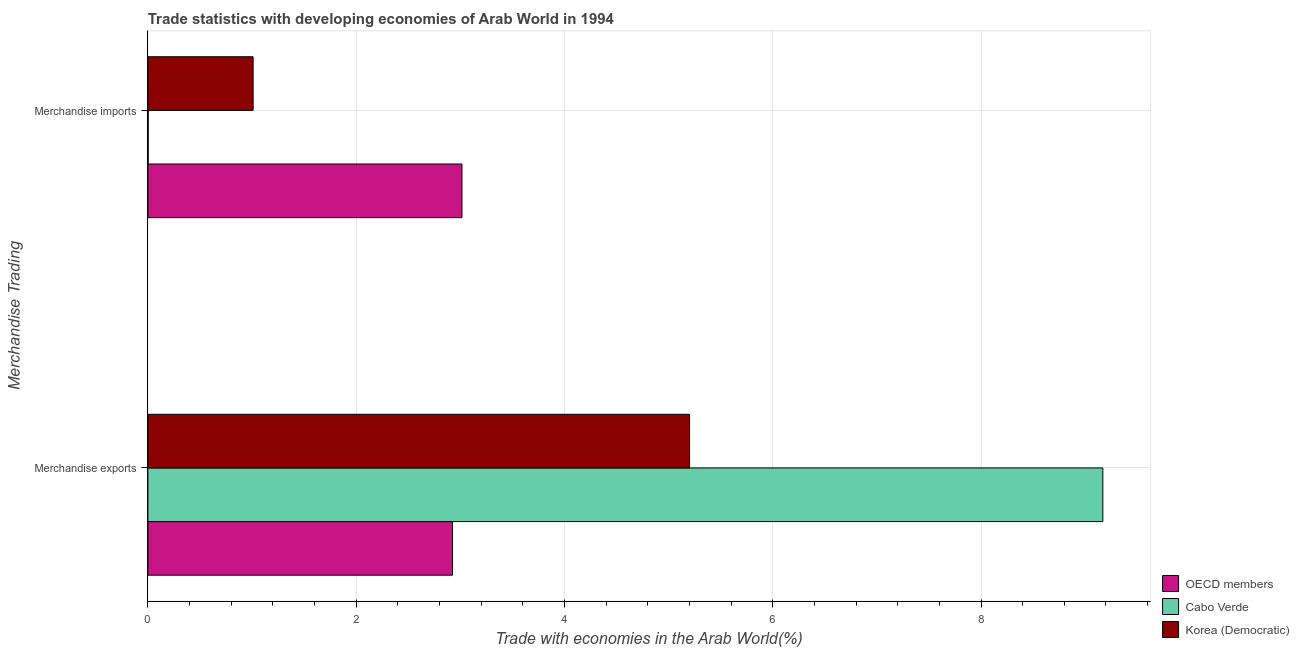Are the number of bars per tick equal to the number of legend labels?
Give a very brief answer. Yes. How many bars are there on the 2nd tick from the top?
Make the answer very short. 3. How many bars are there on the 2nd tick from the bottom?
Your response must be concise. 3. What is the label of the 1st group of bars from the top?
Your answer should be compact. Merchandise imports. What is the merchandise exports in Korea (Democratic)?
Give a very brief answer. 5.2. Across all countries, what is the maximum merchandise imports?
Offer a terse response. 3.02. Across all countries, what is the minimum merchandise exports?
Offer a very short reply. 2.93. In which country was the merchandise exports maximum?
Your response must be concise. Cabo Verde. What is the total merchandise imports in the graph?
Your answer should be compact. 4.03. What is the difference between the merchandise exports in Cabo Verde and that in OECD members?
Offer a terse response. 6.24. What is the difference between the merchandise imports in Korea (Democratic) and the merchandise exports in Cabo Verde?
Give a very brief answer. -8.16. What is the average merchandise exports per country?
Give a very brief answer. 5.77. What is the difference between the merchandise imports and merchandise exports in OECD members?
Offer a terse response. 0.09. In how many countries, is the merchandise exports greater than 0.4 %?
Your response must be concise. 3. What is the ratio of the merchandise exports in Korea (Democratic) to that in Cabo Verde?
Your answer should be compact. 0.57. What does the 3rd bar from the bottom in Merchandise exports represents?
Offer a terse response. Korea (Democratic). Are all the bars in the graph horizontal?
Make the answer very short. Yes. Does the graph contain any zero values?
Offer a very short reply. No. Does the graph contain grids?
Offer a terse response. Yes. What is the title of the graph?
Your answer should be compact. Trade statistics with developing economies of Arab World in 1994. What is the label or title of the X-axis?
Your answer should be compact. Trade with economies in the Arab World(%). What is the label or title of the Y-axis?
Keep it short and to the point. Merchandise Trading. What is the Trade with economies in the Arab World(%) in OECD members in Merchandise exports?
Your response must be concise. 2.93. What is the Trade with economies in the Arab World(%) of Cabo Verde in Merchandise exports?
Give a very brief answer. 9.17. What is the Trade with economies in the Arab World(%) in Korea (Democratic) in Merchandise exports?
Your answer should be very brief. 5.2. What is the Trade with economies in the Arab World(%) in OECD members in Merchandise imports?
Your response must be concise. 3.02. What is the Trade with economies in the Arab World(%) of Cabo Verde in Merchandise imports?
Ensure brevity in your answer.  0. What is the Trade with economies in the Arab World(%) of Korea (Democratic) in Merchandise imports?
Your answer should be very brief. 1.01. Across all Merchandise Trading, what is the maximum Trade with economies in the Arab World(%) in OECD members?
Offer a terse response. 3.02. Across all Merchandise Trading, what is the maximum Trade with economies in the Arab World(%) in Cabo Verde?
Offer a very short reply. 9.17. Across all Merchandise Trading, what is the maximum Trade with economies in the Arab World(%) of Korea (Democratic)?
Offer a very short reply. 5.2. Across all Merchandise Trading, what is the minimum Trade with economies in the Arab World(%) in OECD members?
Make the answer very short. 2.93. Across all Merchandise Trading, what is the minimum Trade with economies in the Arab World(%) in Cabo Verde?
Ensure brevity in your answer.  0. Across all Merchandise Trading, what is the minimum Trade with economies in the Arab World(%) in Korea (Democratic)?
Your response must be concise. 1.01. What is the total Trade with economies in the Arab World(%) in OECD members in the graph?
Offer a very short reply. 5.94. What is the total Trade with economies in the Arab World(%) of Cabo Verde in the graph?
Provide a short and direct response. 9.17. What is the total Trade with economies in the Arab World(%) of Korea (Democratic) in the graph?
Your answer should be very brief. 6.21. What is the difference between the Trade with economies in the Arab World(%) of OECD members in Merchandise exports and that in Merchandise imports?
Ensure brevity in your answer.  -0.09. What is the difference between the Trade with economies in the Arab World(%) in Cabo Verde in Merchandise exports and that in Merchandise imports?
Provide a succinct answer. 9.17. What is the difference between the Trade with economies in the Arab World(%) of Korea (Democratic) in Merchandise exports and that in Merchandise imports?
Your response must be concise. 4.19. What is the difference between the Trade with economies in the Arab World(%) of OECD members in Merchandise exports and the Trade with economies in the Arab World(%) of Cabo Verde in Merchandise imports?
Ensure brevity in your answer.  2.92. What is the difference between the Trade with economies in the Arab World(%) in OECD members in Merchandise exports and the Trade with economies in the Arab World(%) in Korea (Democratic) in Merchandise imports?
Offer a terse response. 1.91. What is the difference between the Trade with economies in the Arab World(%) of Cabo Verde in Merchandise exports and the Trade with economies in the Arab World(%) of Korea (Democratic) in Merchandise imports?
Your answer should be compact. 8.16. What is the average Trade with economies in the Arab World(%) in OECD members per Merchandise Trading?
Offer a very short reply. 2.97. What is the average Trade with economies in the Arab World(%) of Cabo Verde per Merchandise Trading?
Your response must be concise. 4.59. What is the average Trade with economies in the Arab World(%) of Korea (Democratic) per Merchandise Trading?
Provide a short and direct response. 3.11. What is the difference between the Trade with economies in the Arab World(%) of OECD members and Trade with economies in the Arab World(%) of Cabo Verde in Merchandise exports?
Your response must be concise. -6.24. What is the difference between the Trade with economies in the Arab World(%) of OECD members and Trade with economies in the Arab World(%) of Korea (Democratic) in Merchandise exports?
Your response must be concise. -2.28. What is the difference between the Trade with economies in the Arab World(%) in Cabo Verde and Trade with economies in the Arab World(%) in Korea (Democratic) in Merchandise exports?
Give a very brief answer. 3.97. What is the difference between the Trade with economies in the Arab World(%) of OECD members and Trade with economies in the Arab World(%) of Cabo Verde in Merchandise imports?
Provide a succinct answer. 3.01. What is the difference between the Trade with economies in the Arab World(%) of OECD members and Trade with economies in the Arab World(%) of Korea (Democratic) in Merchandise imports?
Keep it short and to the point. 2.01. What is the difference between the Trade with economies in the Arab World(%) of Cabo Verde and Trade with economies in the Arab World(%) of Korea (Democratic) in Merchandise imports?
Your answer should be very brief. -1.01. What is the ratio of the Trade with economies in the Arab World(%) in Cabo Verde in Merchandise exports to that in Merchandise imports?
Give a very brief answer. 2917.88. What is the ratio of the Trade with economies in the Arab World(%) in Korea (Democratic) in Merchandise exports to that in Merchandise imports?
Ensure brevity in your answer.  5.15. What is the difference between the highest and the second highest Trade with economies in the Arab World(%) of OECD members?
Offer a very short reply. 0.09. What is the difference between the highest and the second highest Trade with economies in the Arab World(%) in Cabo Verde?
Give a very brief answer. 9.17. What is the difference between the highest and the second highest Trade with economies in the Arab World(%) in Korea (Democratic)?
Your response must be concise. 4.19. What is the difference between the highest and the lowest Trade with economies in the Arab World(%) in OECD members?
Your response must be concise. 0.09. What is the difference between the highest and the lowest Trade with economies in the Arab World(%) in Cabo Verde?
Your response must be concise. 9.17. What is the difference between the highest and the lowest Trade with economies in the Arab World(%) of Korea (Democratic)?
Offer a terse response. 4.19. 